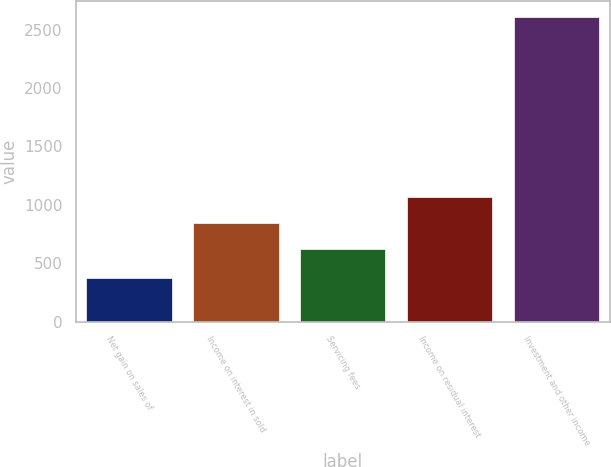<chart> <loc_0><loc_0><loc_500><loc_500><bar_chart><fcel>Net gain on sales of<fcel>Income on interest in sold<fcel>Servicing fees<fcel>Income on residual interest<fcel>Investment and other income<nl><fcel>373<fcel>841.8<fcel>618<fcel>1065.6<fcel>2611<nl></chart> 